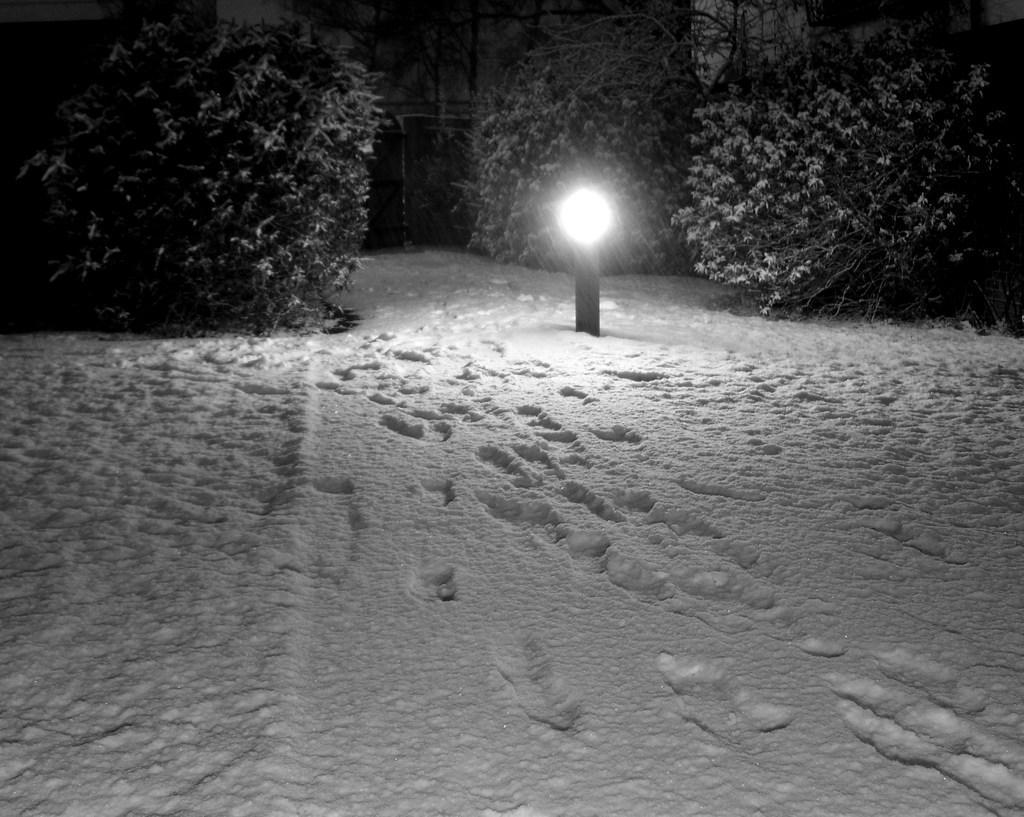Could you give a brief overview of what you see in this image? In this image, we can see some footprints on the snow. There is a light in the middle of the image. There are plants in the top left and in the top right of the image. 